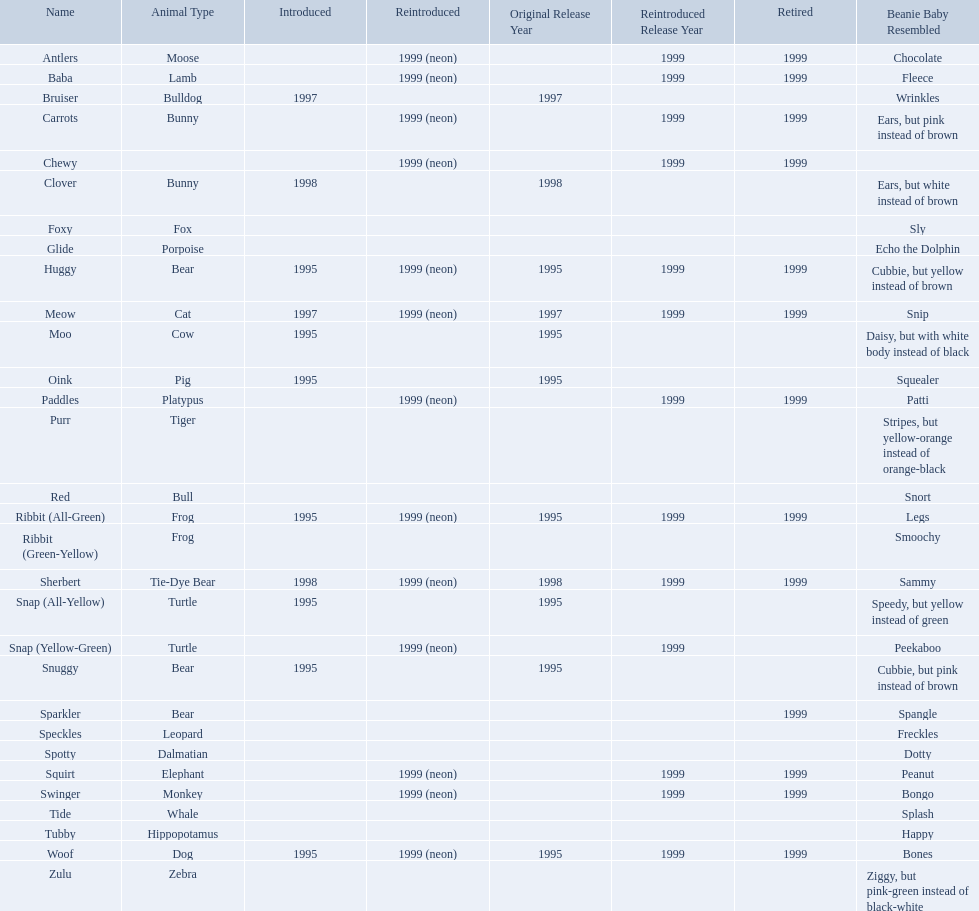What animals are pillow pals? Moose, Lamb, Bulldog, Bunny, Bunny, Fox, Porpoise, Bear, Cat, Cow, Pig, Platypus, Tiger, Bull, Frog, Frog, Tie-Dye Bear, Turtle, Turtle, Bear, Bear, Leopard, Dalmatian, Elephant, Monkey, Whale, Hippopotamus, Dog, Zebra. What is the name of the dalmatian? Spotty. What are the names listed? Antlers, Baba, Bruiser, Carrots, Chewy, Clover, Foxy, Glide, Huggy, Meow, Moo, Oink, Paddles, Purr, Red, Ribbit (All-Green), Ribbit (Green-Yellow), Sherbert, Snap (All-Yellow), Snap (Yellow-Green), Snuggy, Sparkler, Speckles, Spotty, Squirt, Swinger, Tide, Tubby, Woof, Zulu. Of these, which is the only pet without an animal type listed? Chewy. 